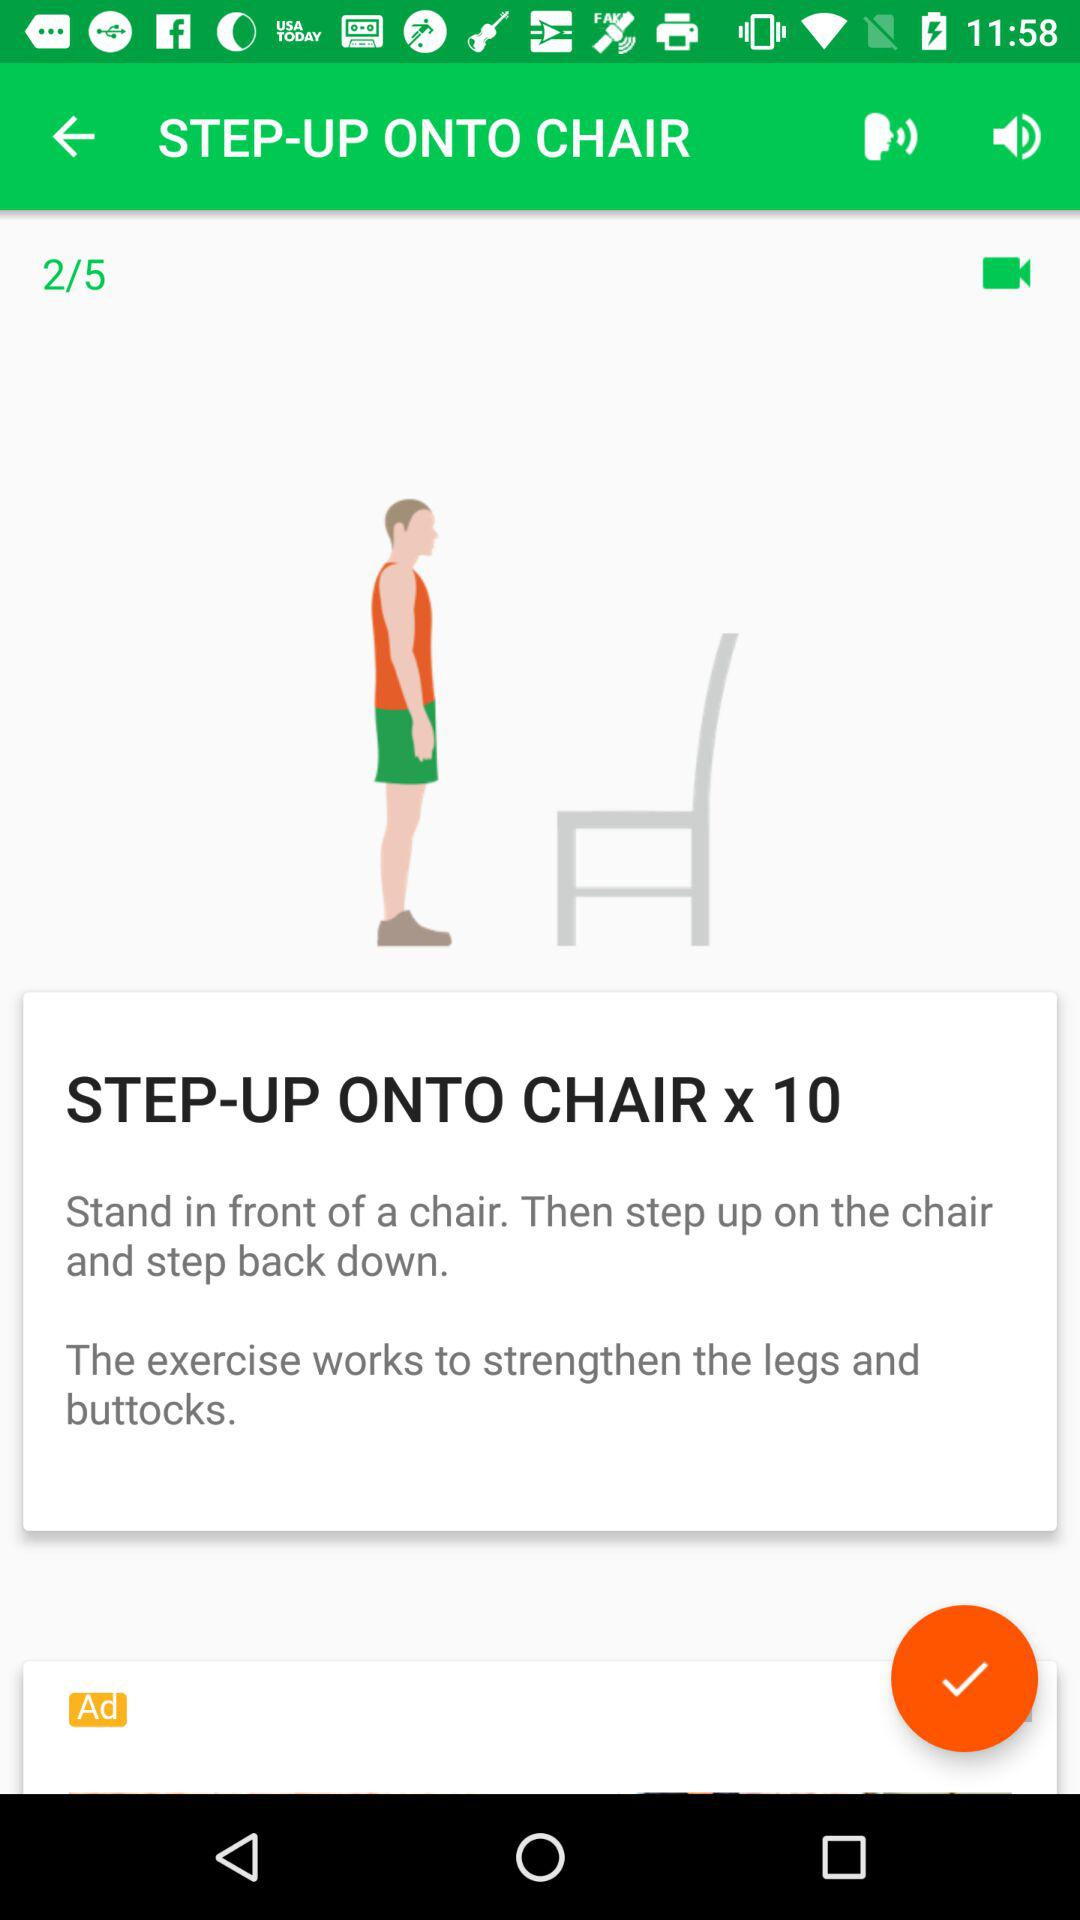How many volume states are there?
Answer the question using a single word or phrase. 2 